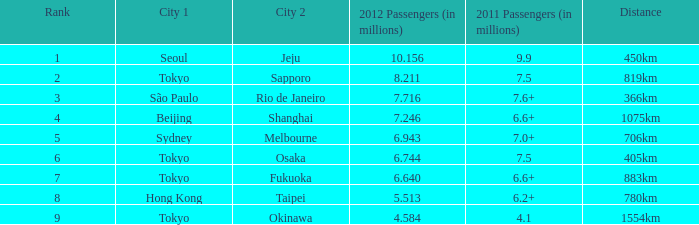What is the foremost city on the route that accommodated Beijing. 